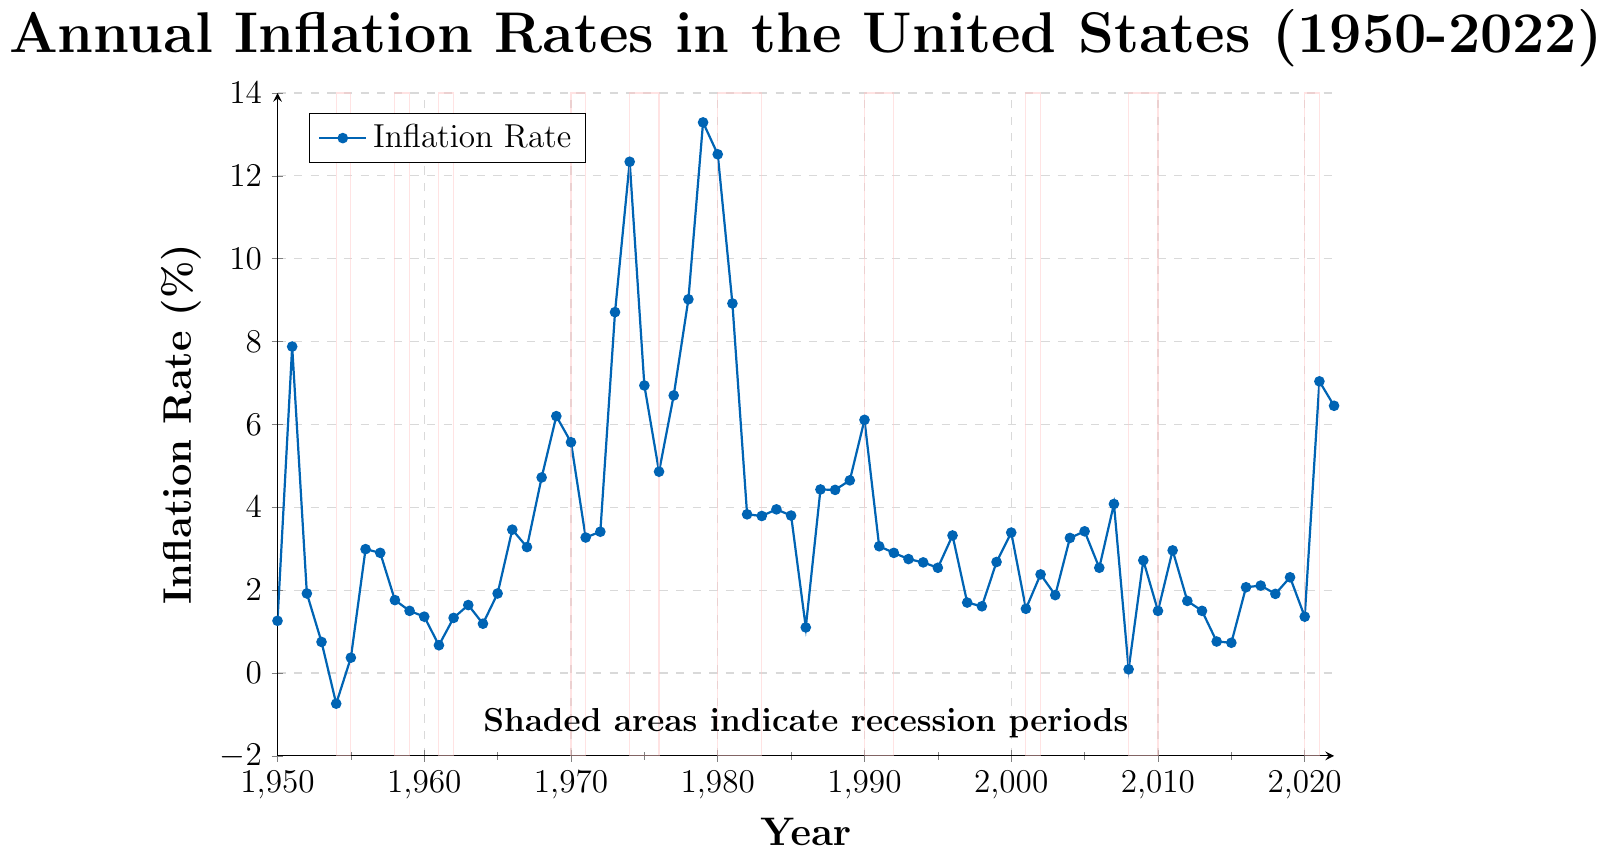Which year had the highest inflation rate? Look at the peak point on the line chart and match it with the corresponding year on the x-axis.
Answer: 1979 During how many recession periods did the inflation rate exceed 10%? Identify the shaded recession areas and count how many of them have the corresponding year's inflation rate above 10%.
Answer: 4 What was the inflation rate during the recession in 1980? Find the shaded area around 1980 on the chart, locate the corresponding year label, and read the inflation rate from the point on the line.
Answer: 12.52% Which period shows the most significant drop in the inflation rate after the recession started? Look at the shaded recession areas and compare the differences in inflation rates at the beginning and end of each period.
Answer: 1981 to 1982 Is there any recession period where the inflation rate was negative? Check all the shaded recession areas and look at the corresponding years to see if any point has a negative inflation rate.
Answer: No What is the average inflation rate during the 1974-1975 recession? Identify the recession period (1974-1975), then calculate the average of the inflation rates for those years [(12.34 + 6.94) / 2].
Answer: 9.64 Compare the inflation rates during the recession periods of 1974 and 2008. Which one was higher? Read the inflation rates for the years corresponding to the 1974 and 2008 recession periods and compare them directly.
Answer: 1974 By how much did the inflation rate change from 1951 to 1954? Find the inflation rates for 1951 and 1954, then calculate their difference (7.88 - (-0.74)).
Answer: 8.62 What is the total number of years with an inflation rate over 5%? Count all the data points on the line chart where the inflation rate exceeds 5%.
Answer: 15 During which recession period did the inflation rate increase rather than decrease during the shaded period? Examine each shaded recession period and compare the starting and ending inflation rates within those periods to see if there was an increase in the inflation rate.
Answer: 2020 